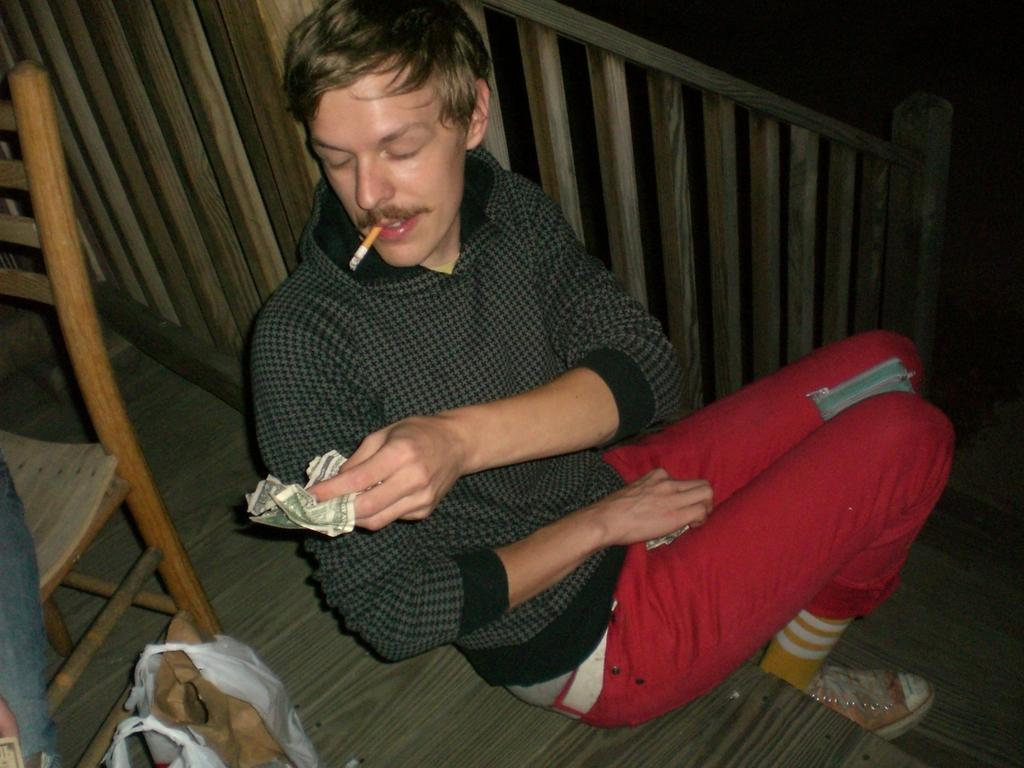What is the man in the image doing? The man is sitting on the stairs. What is the man holding in the image? The man is holding currency notes. What type of furniture is present in the image? There is a chair in the image. What else can be seen in the image besides the man and the chair? There is a bag and an unspecified object in the image. How many bikes are visible in the image? There are no bikes present in the image. What type of balls can be seen in the image? There are no balls present in the image. 